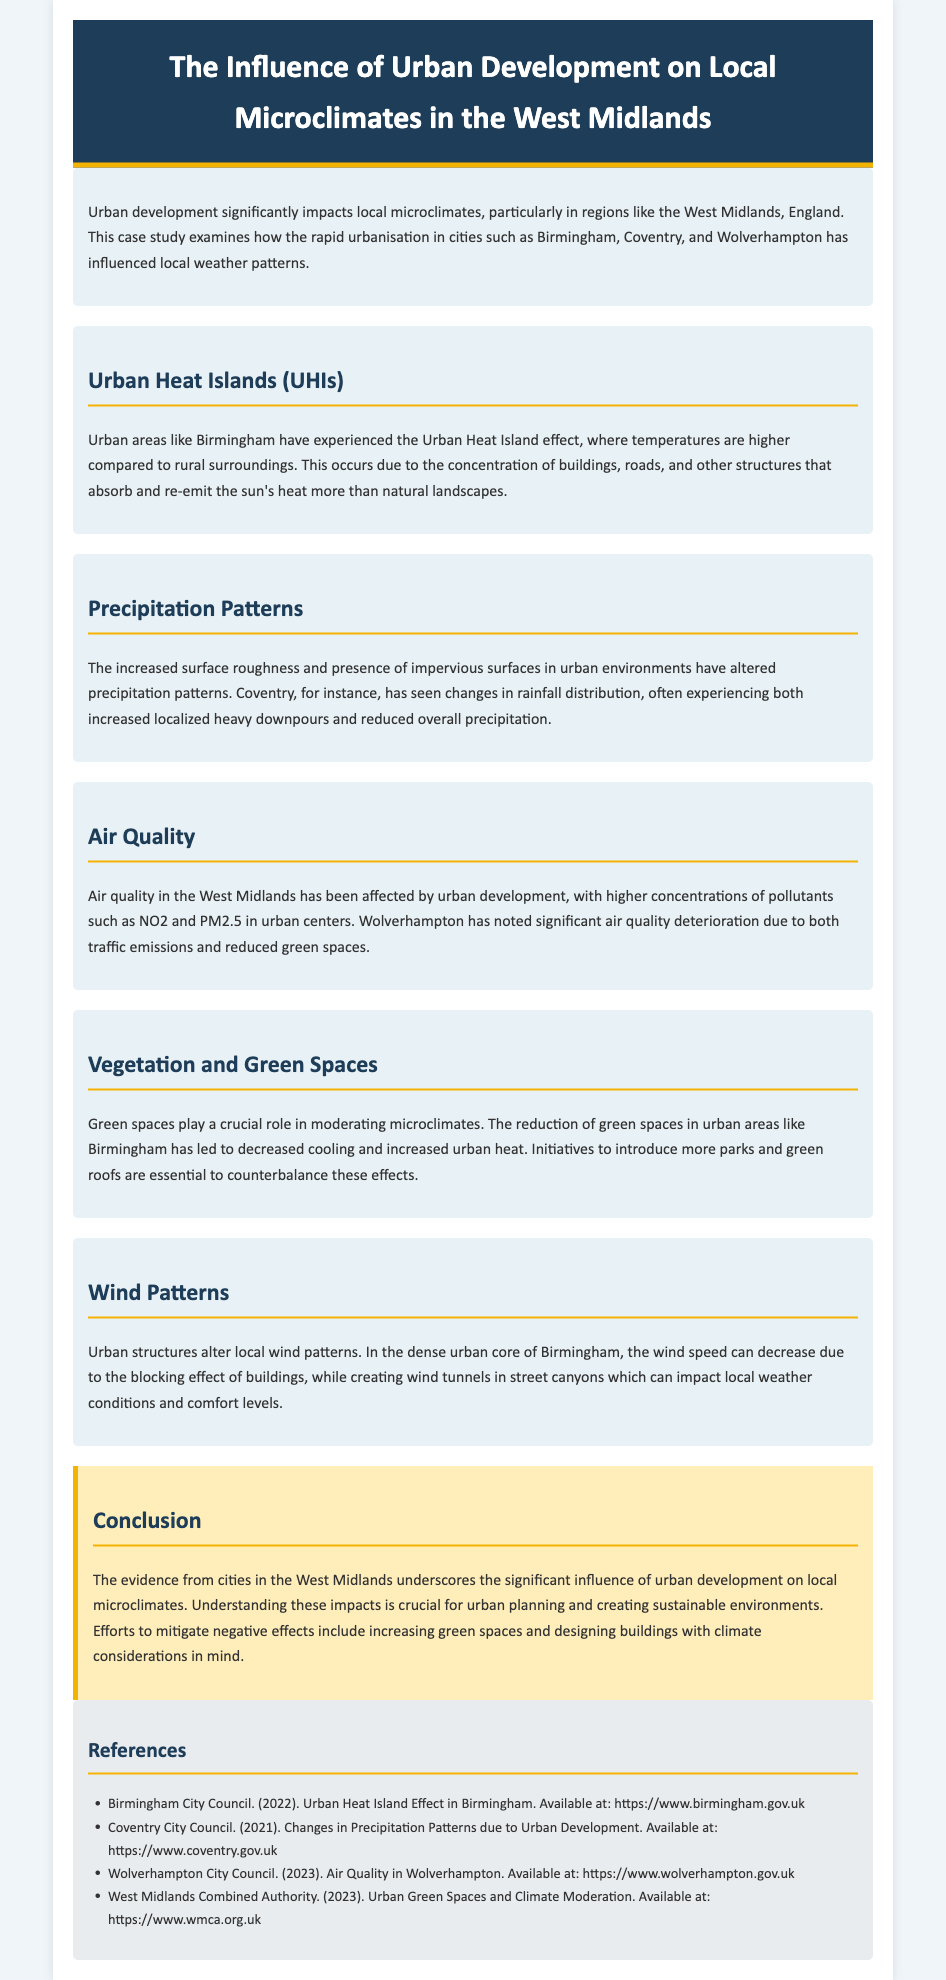What is the title of the case study? The title can be found in the header section of the document.
Answer: The Influence of Urban Development on Local Microclimates in the West Midlands Which city is specifically mentioned regarding the Urban Heat Island effect? The Urban Heat Island effect is discussed in the section about UHIs.
Answer: Birmingham What alters precipitation patterns in urban environments? The document notes several changes related to urban structures and surfaces that affect precipitation.
Answer: Increased surface roughness and impervious surfaces What has Wolverhampton noted about air quality? This information is provided in the air quality section discussing urban development effects.
Answer: Significant air quality deterioration What role do green spaces play in urban microclimates? The document explains the importance of green spaces in moderating temperature and climate conditions.
Answer: Modulating microclimates How can negative urban development effects be mitigated according to the conclusion? The conclusion section suggests measures for urban planning.
Answer: Increasing green spaces and designing buildings with climate considerations What type of document is presented here? The structure and focus of the content indicate its classification.
Answer: Case study 